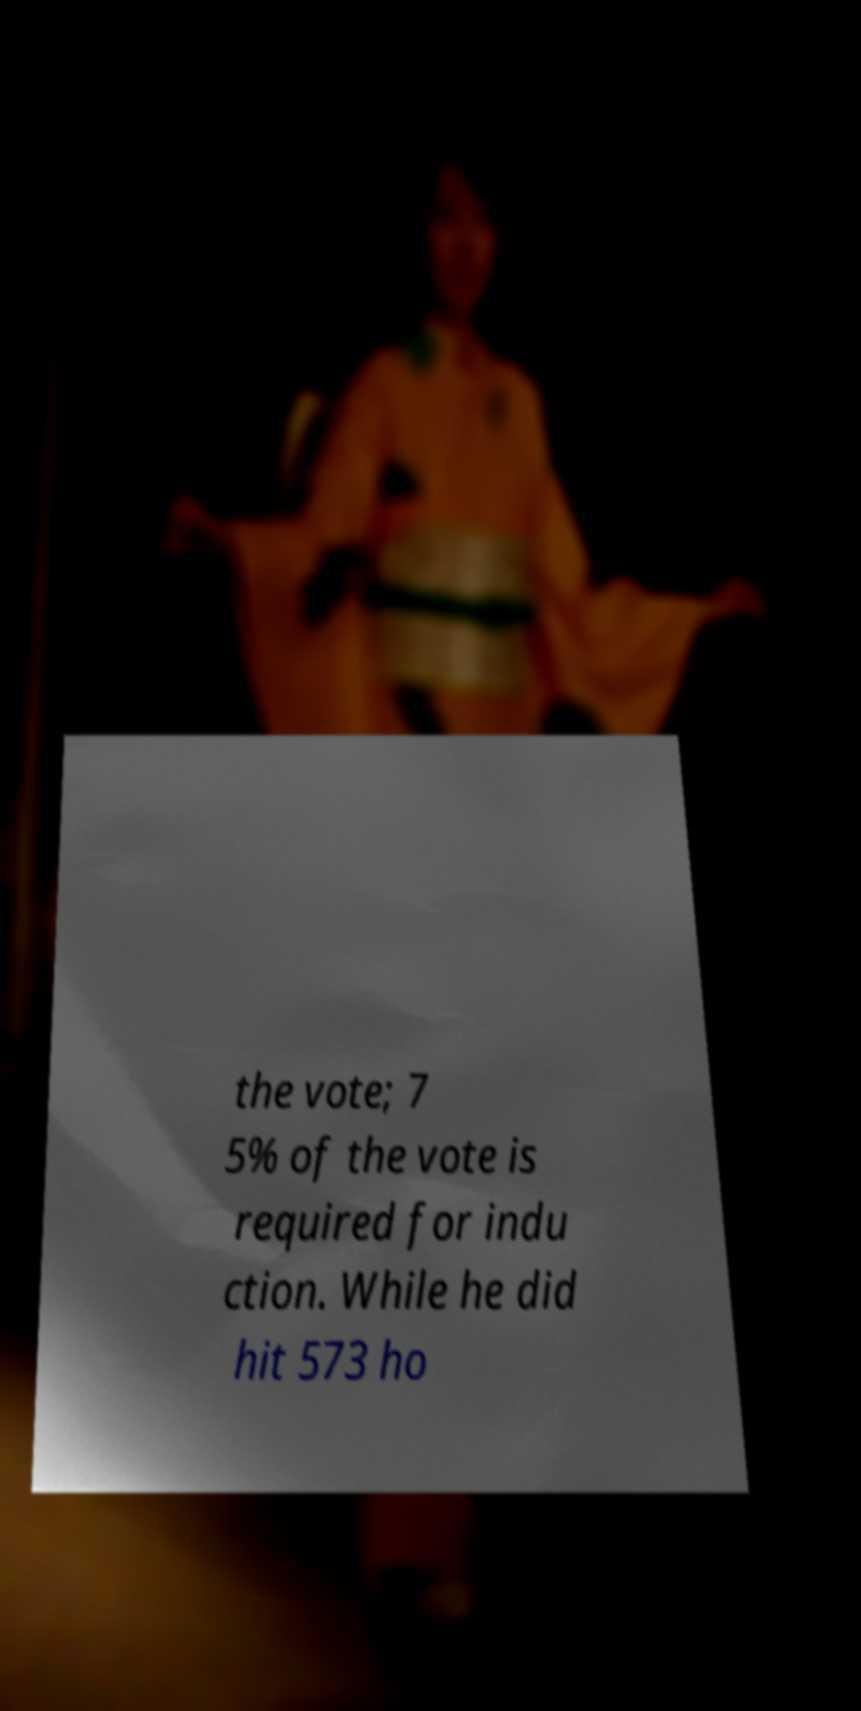Can you accurately transcribe the text from the provided image for me? the vote; 7 5% of the vote is required for indu ction. While he did hit 573 ho 